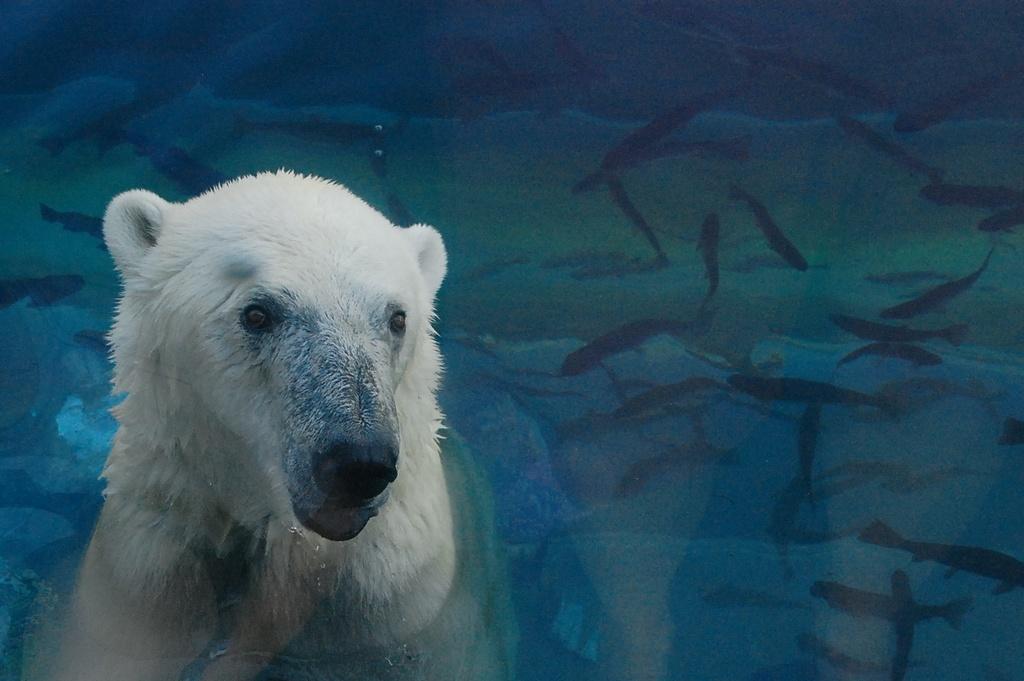Describe this image in one or two sentences. In this image we can see an animal and the fishes in the water. 